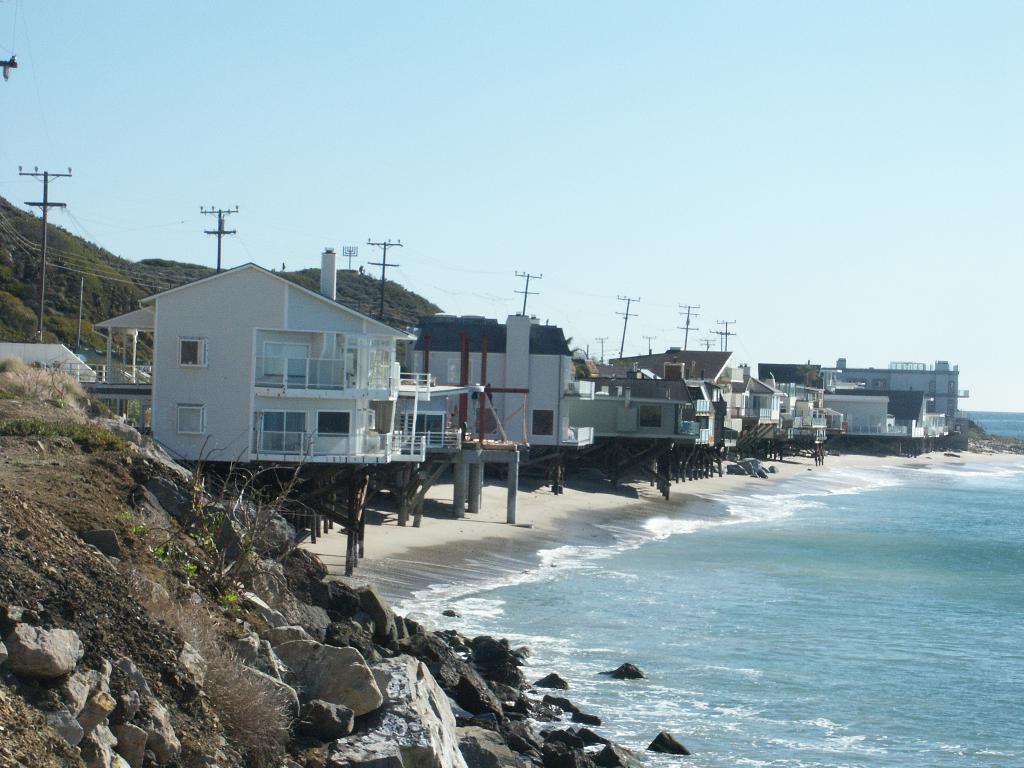Describe this image in one or two sentences. In this image I can see the water, background I can see few buildings in white and brown color, few electric poles, trees in green color and the sky is in blue and white color. 